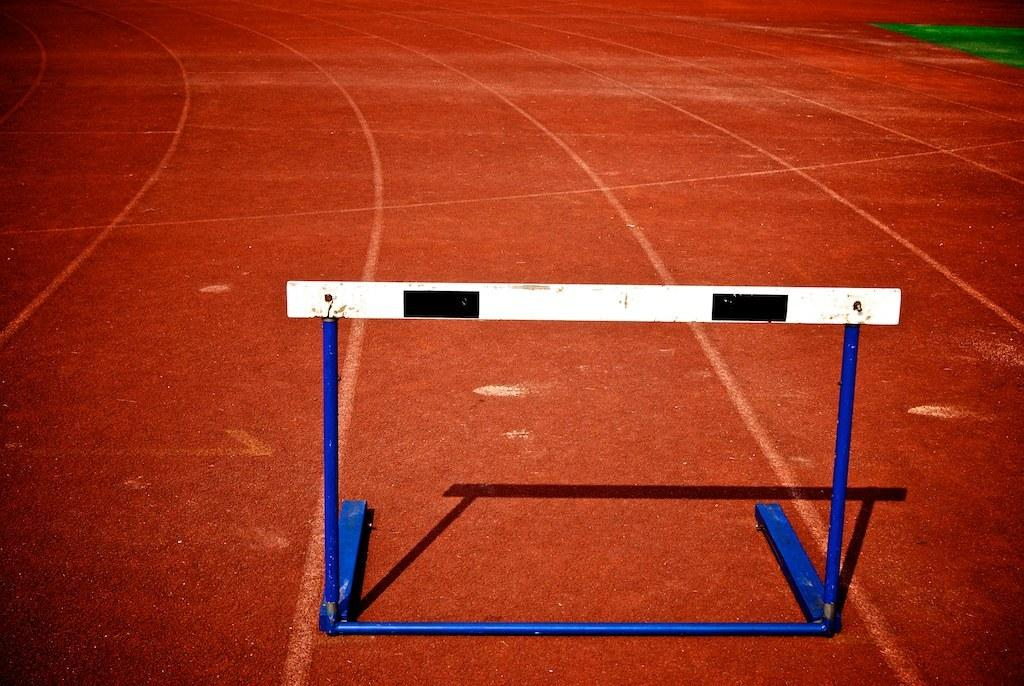What is the main object in the image? There is a stand in the image. Where is the stand located? The stand is placed on the ground. What does the mom say about the size of the alley in the image? There is no mention of a mom, size, or alley in the image. 